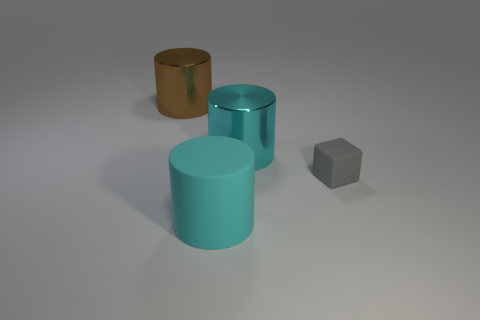What is the color of the tiny rubber thing?
Provide a short and direct response. Gray. There is a shiny cylinder to the right of the object that is in front of the gray object; what is its color?
Your response must be concise. Cyan. The shiny thing that is on the right side of the big metallic cylinder that is left of the cylinder in front of the small cube is what shape?
Keep it short and to the point. Cylinder. What number of other small gray cubes have the same material as the cube?
Your answer should be very brief. 0. There is a brown metallic cylinder that is left of the gray object; how many big cyan cylinders are to the left of it?
Give a very brief answer. 0. How many cyan balls are there?
Keep it short and to the point. 0. Is the material of the tiny gray block the same as the large cyan cylinder behind the gray thing?
Offer a terse response. No. Is the color of the large metallic cylinder that is in front of the large brown metal object the same as the rubber cylinder?
Your answer should be very brief. Yes. The cylinder that is both to the left of the large cyan shiny thing and to the right of the big brown metallic object is made of what material?
Ensure brevity in your answer.  Rubber. What size is the brown shiny cylinder?
Provide a short and direct response. Large. 